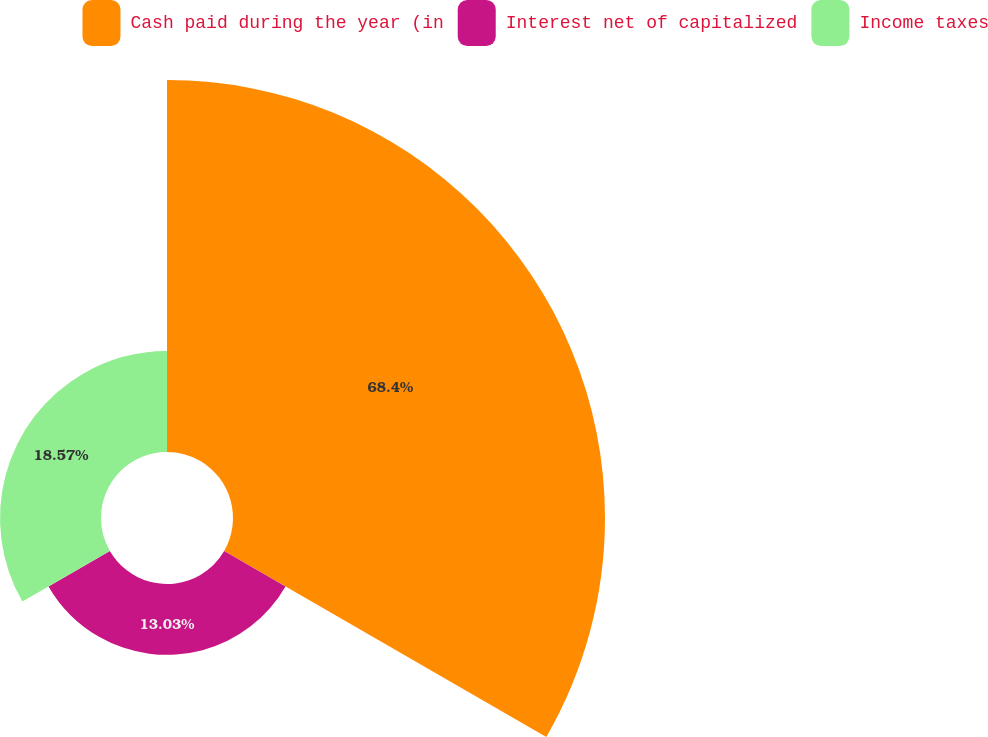Convert chart. <chart><loc_0><loc_0><loc_500><loc_500><pie_chart><fcel>Cash paid during the year (in<fcel>Interest net of capitalized<fcel>Income taxes<nl><fcel>68.4%<fcel>13.03%<fcel>18.57%<nl></chart> 